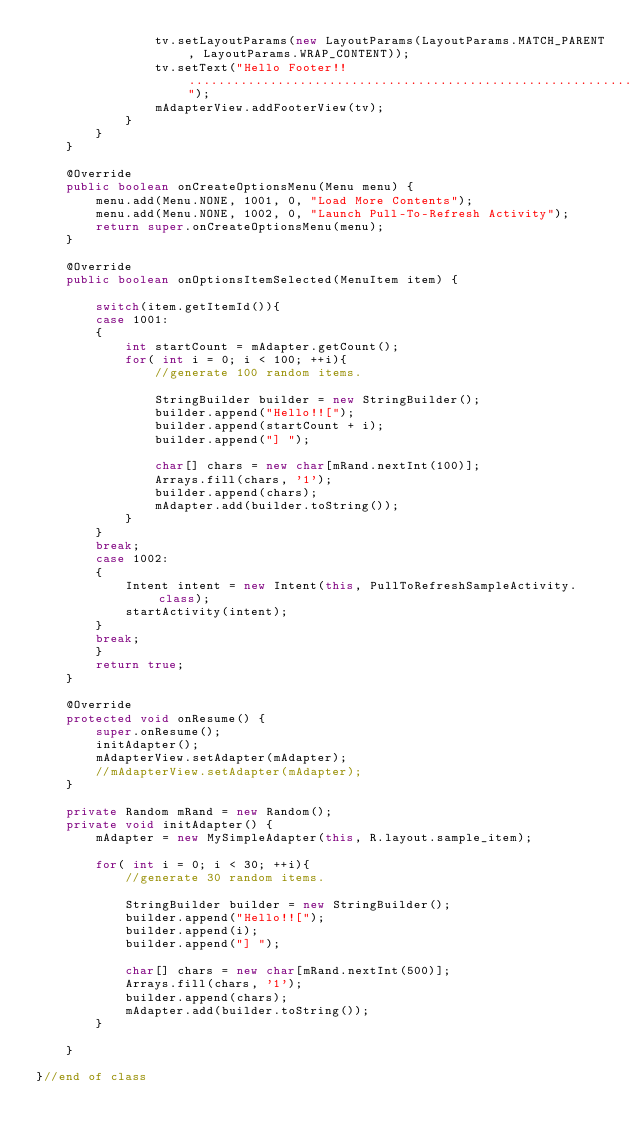<code> <loc_0><loc_0><loc_500><loc_500><_Java_>				tv.setLayoutParams(new LayoutParams(LayoutParams.MATCH_PARENT, LayoutParams.WRAP_CONTENT));
				tv.setText("Hello Footer!! ........................................................................");
				mAdapterView.addFooterView(tv);
			}
		}
	}

	@Override
	public boolean onCreateOptionsMenu(Menu menu) {
		menu.add(Menu.NONE, 1001, 0, "Load More Contents");
		menu.add(Menu.NONE, 1002, 0, "Launch Pull-To-Refresh Activity");
		return super.onCreateOptionsMenu(menu);
	}

	@Override
	public boolean onOptionsItemSelected(MenuItem item) {

		switch(item.getItemId()){
		case 1001:
		{
			int startCount = mAdapter.getCount();
			for( int i = 0; i < 100; ++i){
				//generate 100 random items.

				StringBuilder builder = new StringBuilder();
				builder.append("Hello!![");
				builder.append(startCount + i);
				builder.append("] ");

				char[] chars = new char[mRand.nextInt(100)];
				Arrays.fill(chars, '1');
				builder.append(chars);
				mAdapter.add(builder.toString());
			}
		}
		break;
		case 1002:
		{
			Intent intent = new Intent(this, PullToRefreshSampleActivity.class);
			startActivity(intent);
		}
		break;
		}
		return true;
	}

	@Override
	protected void onResume() {
		super.onResume();
		initAdapter();
		mAdapterView.setAdapter(mAdapter);
		//mAdapterView.setAdapter(mAdapter);
	}

	private Random mRand = new Random();
	private void initAdapter() {
		mAdapter = new MySimpleAdapter(this, R.layout.sample_item);

		for( int i = 0; i < 30; ++i){
			//generate 30 random items.

			StringBuilder builder = new StringBuilder();
			builder.append("Hello!![");
			builder.append(i);
			builder.append("] ");

			char[] chars = new char[mRand.nextInt(500)];
			Arrays.fill(chars, '1');
			builder.append(chars);
			mAdapter.add(builder.toString());
		}

	}

}//end of class
</code> 